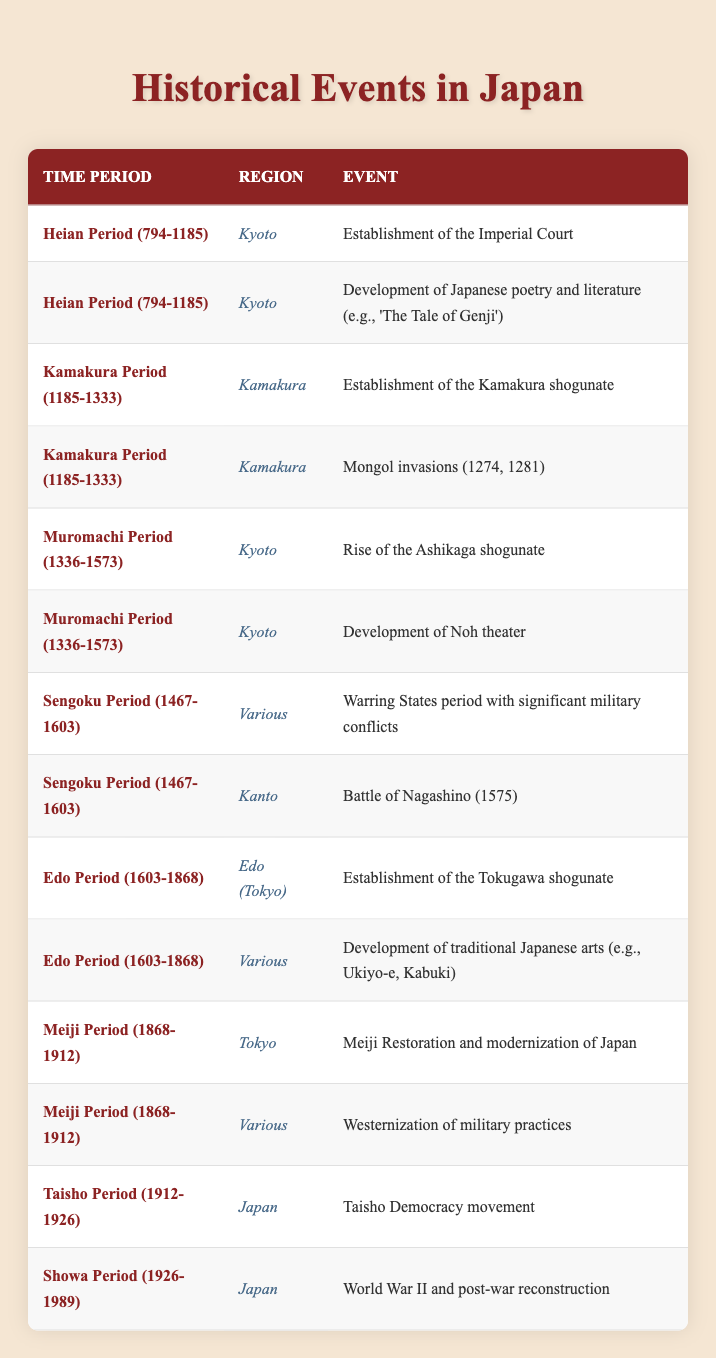What events occurred in the Heian Period? In the Heian Period (794-1185), two events are listed: the establishment of the Imperial Court and the development of Japanese poetry and literature, such as 'The Tale of Genji.'
Answer: Establishment of the Imperial Court, Development of Japanese poetry and literature (e.g., 'The Tale of Genji') How many events took place in Kyoto during the Muromachi Period? In the Muromachi Period (1336-1573), there are two events recorded for Kyoto: the rise of the Ashikaga shogunate and the development of Noh theater. Thus, the count of events is two.
Answer: 2 Did the Kamakura period witness any major invasions? Yes, the Kamakura Period (1185-1333) experienced major invasions, specifically the Mongol invasions in 1274 and 1281.
Answer: Yes Which region was most frequently associated with events during the Edo Period? The Edo Period (1603-1868) has two specific events listed for two regions: Edo (Tokyo) and Various. However, since "Various" is not a specific region, the most frequently associated region is Edo (Tokyo) with one event.
Answer: Edo (Tokyo) What is the total number of historical events documented from the Meiji to the Showa Periods? The Meiji Period (1868-1912) has two events, the Taisho Period (1912-1926) has one event, and the Showa Period (1926-1989) has one event. Adding these gives 2 + 1 + 1 = 4 events in total documented in this timeframe.
Answer: 4 How many events in total are listed in the table? By counting all the events listed across all periods, there are 14 historical events documented in the table.
Answer: 14 Was the World War II and post-war reconstruction event marked in any specific region? Yes, the event related to World War II and post-war reconstruction occurred in Japan during the Showa Period (1926-1989).
Answer: Yes Which period had significant military conflicts, and what were they called? The Sengoku Period (1467-1603) is noted for its significant military conflicts, referred to as the Warring States period.
Answer: Sengoku Period, Warring States period 